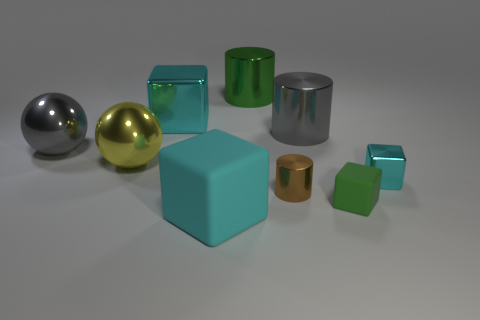Subtract all cyan cylinders. How many cyan blocks are left? 3 Subtract all green cylinders. How many cylinders are left? 2 Add 1 large green metal things. How many objects exist? 10 Subtract all purple blocks. Subtract all brown spheres. How many blocks are left? 4 Subtract all blocks. How many objects are left? 5 Add 7 large yellow metallic spheres. How many large yellow metallic spheres exist? 8 Subtract 0 purple balls. How many objects are left? 9 Subtract all yellow things. Subtract all tiny cyan objects. How many objects are left? 7 Add 1 large objects. How many large objects are left? 7 